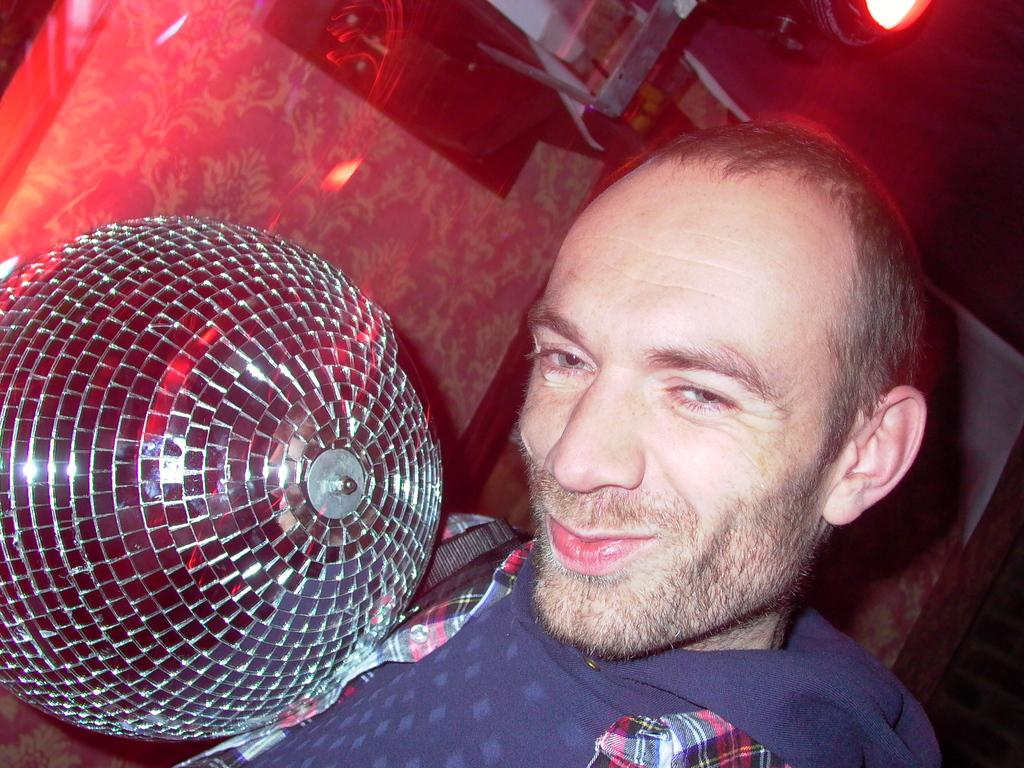What is the main subject of the image? There is a person in the image. How is the person's expression in the image? The person is smiling. What can be seen in the background of the image? There is a light in the background of the image. What type of punishment is the person receiving in the image? There is no indication of punishment in the image; the person is smiling. How many friends are present in the image? The facts provided do not mention any friends, so we cannot determine the number of friends present in the image. 